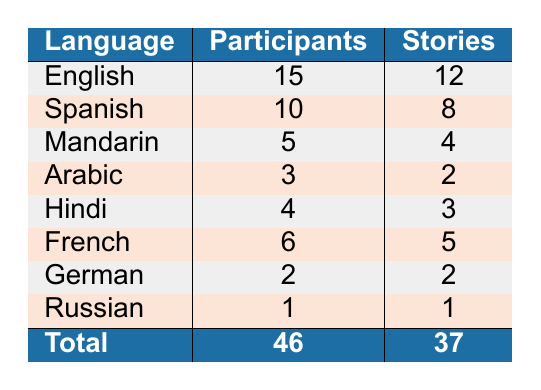What is the total number of participants in the storytelling program? By looking at the table, the total number of participants is shown under the "Total" row in the "Participants" column, which is 46.
Answer: 46 How many stories were shared in Spanish? The number of stories shared in Spanish is listed in the "Stories" column for Spanish, which is 8.
Answer: 8 Which language has the highest number of participants? In the "Participants" column, English has the highest count with 15 participants compared to other languages.
Answer: English Is the number of stories shared in Hindi greater than the number of Hindi-speaking participants? The table shows that 3 stories were shared in Hindi, while there were 4 Hindi-speaking participants. Since 3 is not greater than 4, the answer is no.
Answer: No What is the difference between the number of participants who speak Arabic and the number of stories shared in Arabic? There are 3 participants who speak Arabic and 2 stories shared in Arabic. We subtract the number of stories from the number of participants: 3 - 2 = 1.
Answer: 1 How many more participants speak Spanish than those who speak Russian? The table shows that 10 participants speak Spanish and 1 participant speaks Russian. We subtract 1 from 10 to find the difference: 10 - 1 = 9.
Answer: 9 On average, how many stories were shared per participant? The total number of stories is 37, and the total number of participants is 46. To find the average, we divide the total stories by the number of participants: 37 / 46 ≈ 0.80.
Answer: 0.80 Which language has the highest ratio of stories shared to participants? To find the ratio for each language, we divide the number of stories by the number of participants for each language. English = 12/15 = 0.8, Spanish = 8/10 = 0.8, Mandarin = 4/5 = 0.8, Arabic = 2/3 ≈ 0.67, Hindi = 3/4 = 0.75, French = 5/6 ≈ 0.83, German = 2/2 = 1, Russian = 1/1 = 1. German and Russian both have a ratio of 1, which is the highest.
Answer: German and Russian Are there any languages for which the number of stories shared equals the number of participants? By examining the table, we can see that German has 2 participants and 2 stories shared, and Russian has 1 participant and 1 story shared. Therefore, there are languages where the number of stories equals the number of participants, making the answer yes.
Answer: Yes 